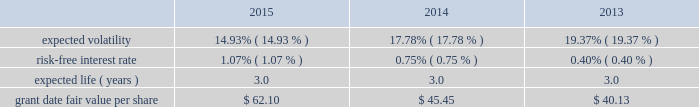During 2012 , the company granted selected employees an aggregate of 139 thousand rsus with internal performance measures and , separately , certain market thresholds .
These awards vested in january 2015 .
The terms of the grants specified that to the extent certain performance goals , comprised of internal measures and , separately , market thresholds were achieved , the rsus would vest ; if performance goals were surpassed , up to 175% ( 175 % ) of the target awards would be distributed ; and if performance goals were not met , the awards would be forfeited .
In january 2015 , an additional 93 thousand rsus were granted and distributed because performance thresholds were exceeded .
In 2015 , 2014 and 2013 , the company granted rsus , both with and without performance conditions , to certain employees under the 2007 plan .
The rsus without performance conditions vest ratably over the three- year service period beginning january 1 of the year of the grant and the rsus with performance conditions vest ratably over the three-year performance period beginning january 1 of the year of the grant ( the 201cperformance period 201d ) .
Distribution of the performance shares is contingent upon the achievement of internal performance measures and , separately , certain market thresholds over the performance period .
During 2015 , 2014 and 2013 , the company granted rsus to non-employee directors under the 2007 plan .
The rsus vested on the date of grant ; however , distribution of the shares will be made within 30 days of the earlier of : ( i ) 15 months after grant date , subject to any deferral election by the director ; or ( ii ) the participant 2019s separation from service .
Because these rsus vested on the grant date , the total grant date fair value was recorded in operation and maintenance expense included in the expense table above on the grant date .
Rsus generally vest over periods ranging from one to three years .
Rsus granted with service-only conditions and those with internal performance measures are valued at the market value of the closing price of the company 2019s common stock on the date of grant .
Rsus granted with market conditions are valued using a monte carlo model .
Expected volatility is based on historical volatilities of traded common stock of the company and comparative companies using daily stock prices over the past three years .
The expected term is three years and the risk-free interest rate is based on the three-year u.s .
Treasury rate in effect as of the measurement date .
The table presents the weighted-average assumptions used in the monte carlo simulation and the weighted-average grant date fair values of rsus granted for the years ended december 31: .
The grant date fair value of restricted stock awards that vest ratably and have market and/or performance and service conditions are amortized through expense over the requisite service period using the graded-vesting method .
Rsus that have no performance conditions are amortized through expense over the requisite service period using the straight-line method and are included in operations expense in the accompanying consolidated statements of operations .
As of december 31 , 2015 , $ 4 of total unrecognized compensation cost related to the nonvested restricted stock units is expected to be recognized over the weighted-average remaining life of 1.4 years .
The total grant date fair value of rsus vested was $ 12 , $ 11 and $ 9 for the years ended december 31 , 2015 , 2014 and 2013. .
What was the growth rate of the grant date fair value of rsus vested from 2013 to 2014? 
Rationale: the change in grant date fair value of rsus vested from 2013 to 2014 was the ( 2014 amount less 2013 amount ) divide by 2013 amount
Computations: ((11 - 9) / 9)
Answer: 0.22222. 